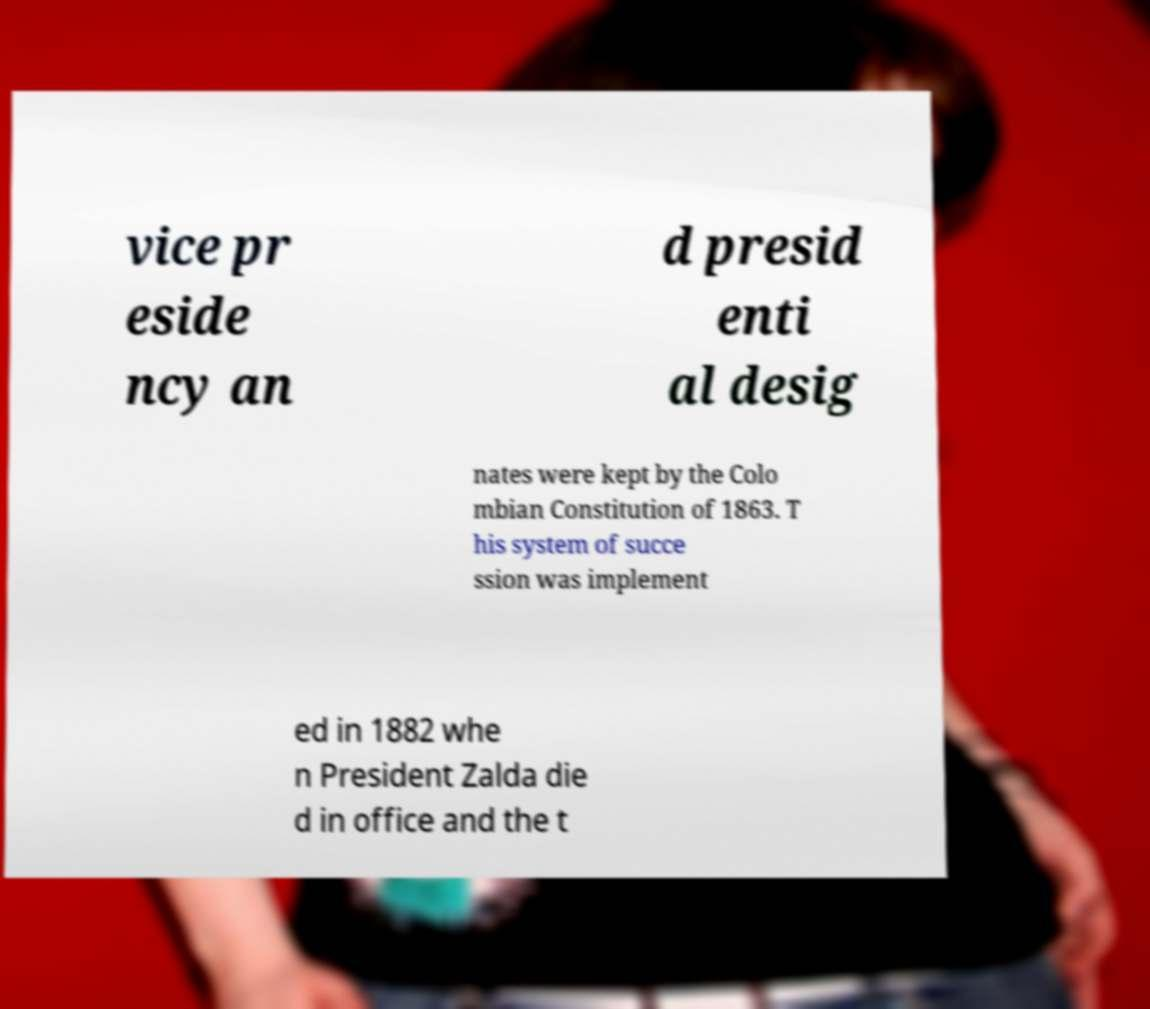Could you extract and type out the text from this image? vice pr eside ncy an d presid enti al desig nates were kept by the Colo mbian Constitution of 1863. T his system of succe ssion was implement ed in 1882 whe n President Zalda die d in office and the t 